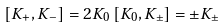Convert formula to latex. <formula><loc_0><loc_0><loc_500><loc_500>[ K _ { + } , K _ { - } ] = 2 K _ { 0 } \, [ K _ { 0 } , K _ { \pm } ] = \pm K _ { \pm }</formula> 